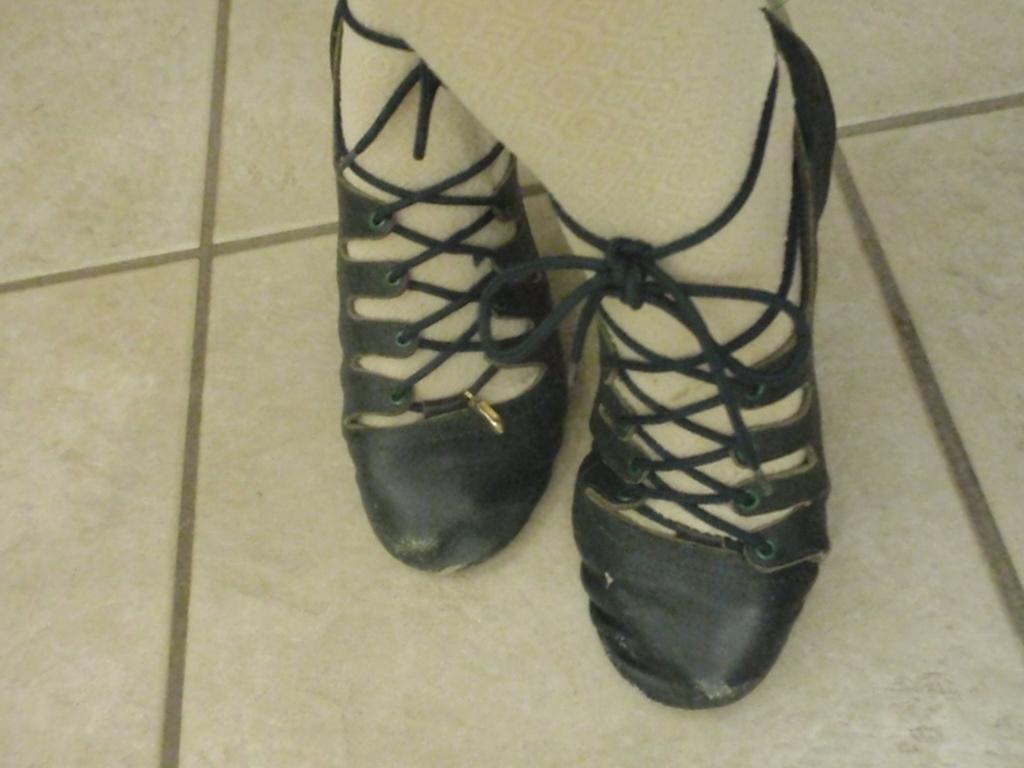In one or two sentences, can you explain what this image depicts? In this image I can see the person's legs with the footwear and I can see the cream color background. 